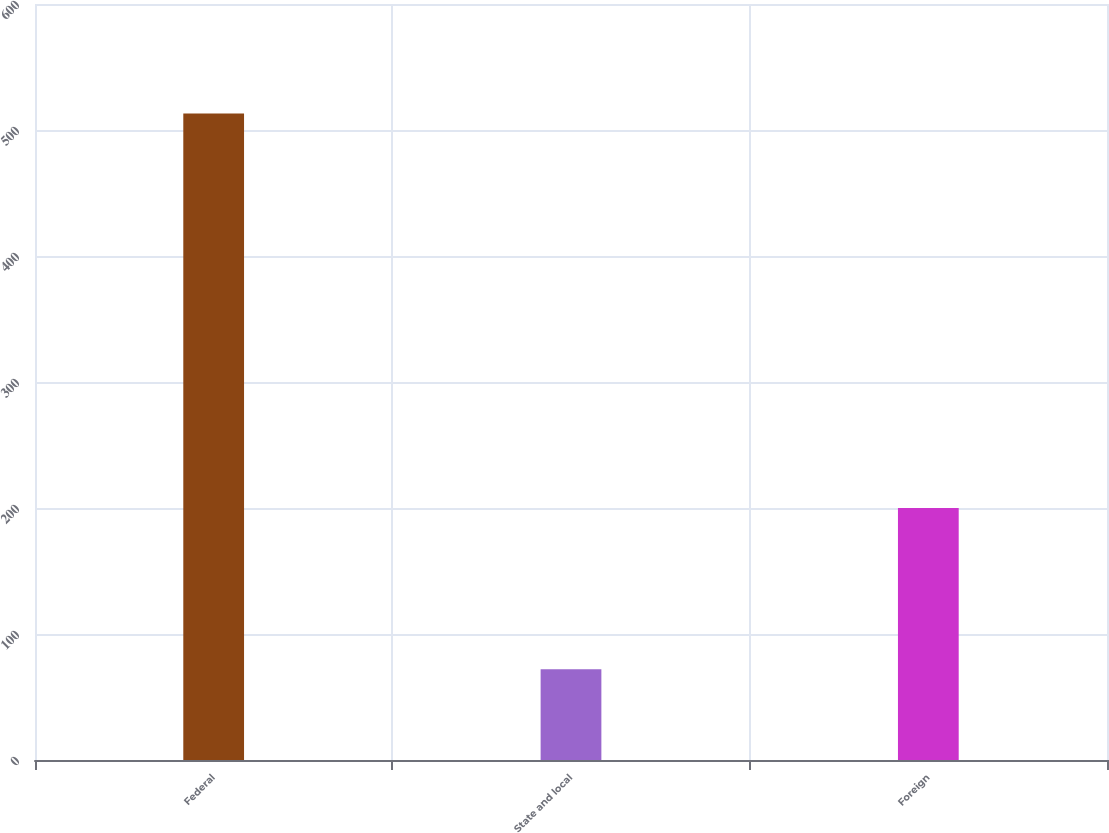Convert chart to OTSL. <chart><loc_0><loc_0><loc_500><loc_500><bar_chart><fcel>Federal<fcel>State and local<fcel>Foreign<nl><fcel>513<fcel>72<fcel>200<nl></chart> 